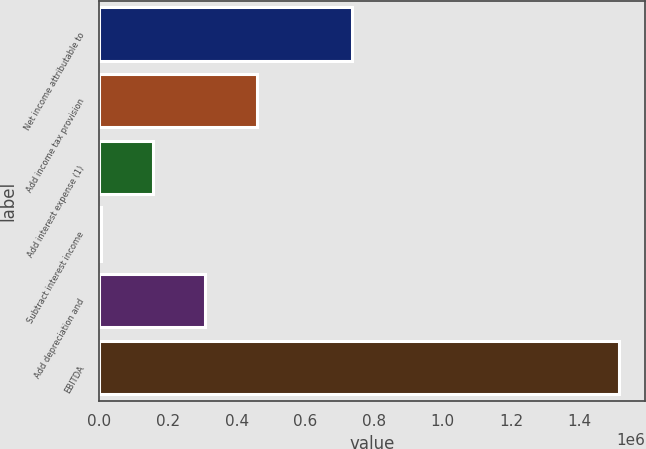<chart> <loc_0><loc_0><loc_500><loc_500><bar_chart><fcel>Net income attributable to<fcel>Add income tax provision<fcel>Add interest expense (1)<fcel>Subtract interest income<fcel>Add depreciation and<fcel>EBITDA<nl><fcel>735842<fcel>458529<fcel>156547<fcel>5556<fcel>307538<fcel>1.51547e+06<nl></chart> 